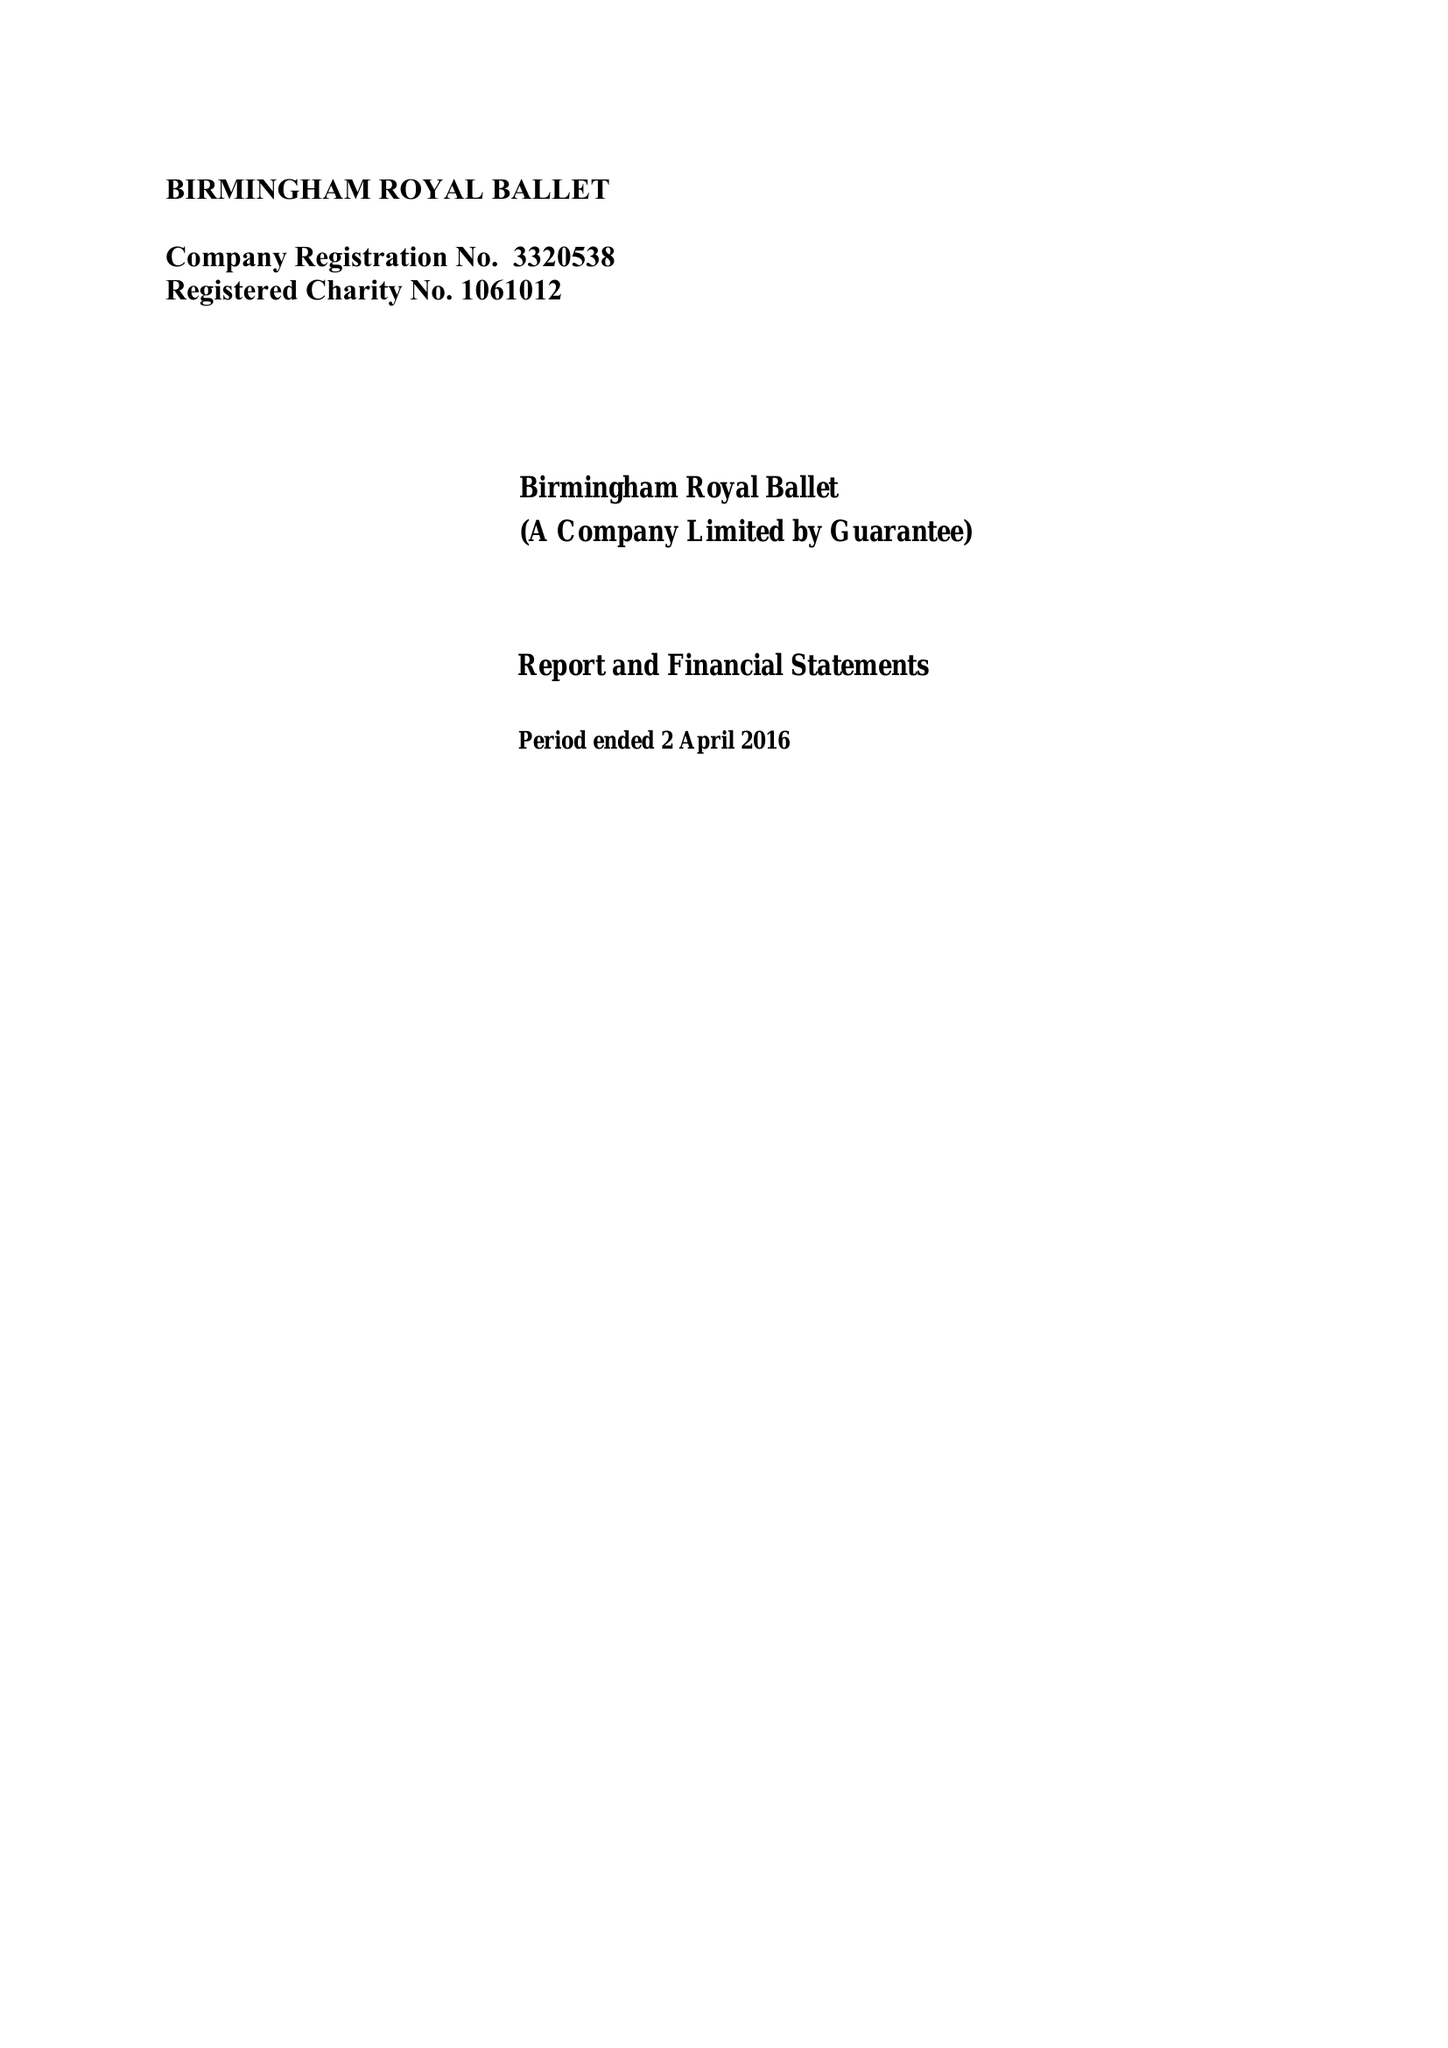What is the value for the address__post_town?
Answer the question using a single word or phrase. BIRMINGHAM 